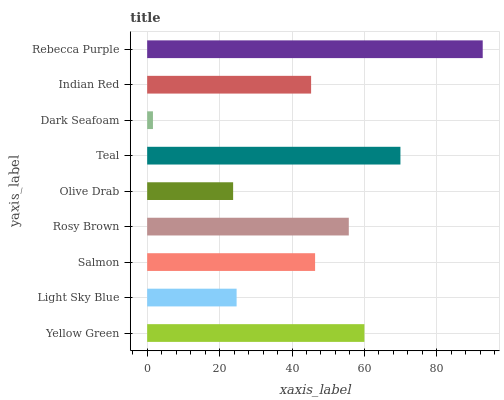Is Dark Seafoam the minimum?
Answer yes or no. Yes. Is Rebecca Purple the maximum?
Answer yes or no. Yes. Is Light Sky Blue the minimum?
Answer yes or no. No. Is Light Sky Blue the maximum?
Answer yes or no. No. Is Yellow Green greater than Light Sky Blue?
Answer yes or no. Yes. Is Light Sky Blue less than Yellow Green?
Answer yes or no. Yes. Is Light Sky Blue greater than Yellow Green?
Answer yes or no. No. Is Yellow Green less than Light Sky Blue?
Answer yes or no. No. Is Salmon the high median?
Answer yes or no. Yes. Is Salmon the low median?
Answer yes or no. Yes. Is Light Sky Blue the high median?
Answer yes or no. No. Is Dark Seafoam the low median?
Answer yes or no. No. 